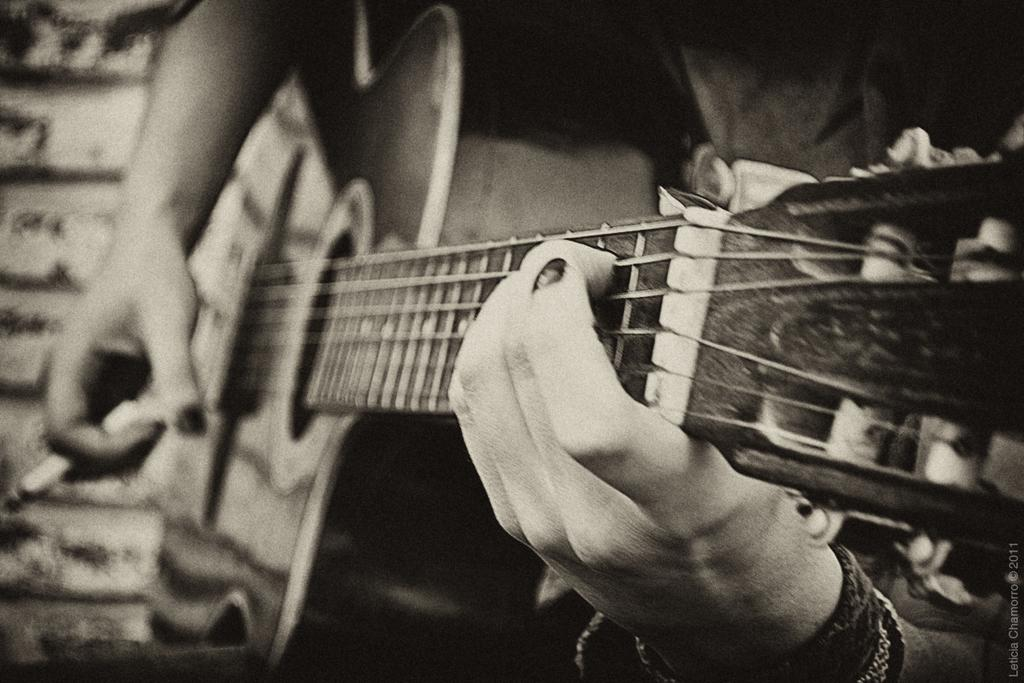What musical instrument is featured in the image? There is a guitar in the image. What is happening with the guitar in the image? Two hands are playing the guitar in the image. What is the chance of winning a lottery in the image? There is no mention of a lottery or winning a lottery in the image, so it's not possible to determine the chance of winning. 